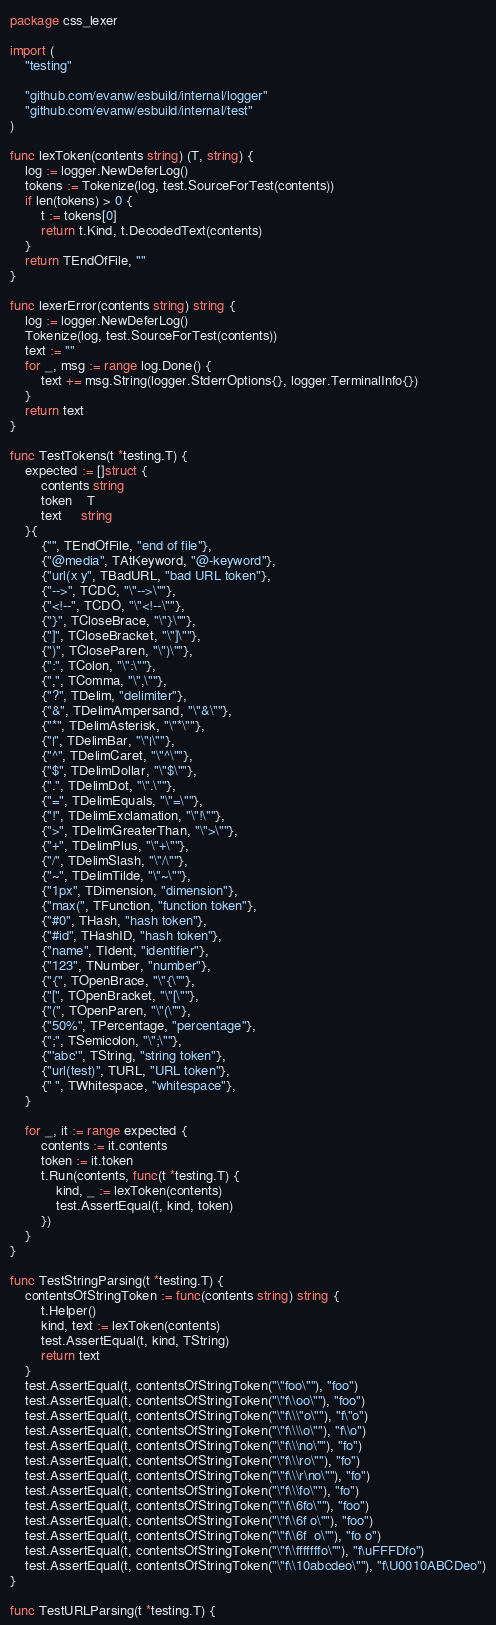Convert code to text. <code><loc_0><loc_0><loc_500><loc_500><_Go_>package css_lexer

import (
	"testing"

	"github.com/evanw/esbuild/internal/logger"
	"github.com/evanw/esbuild/internal/test"
)

func lexToken(contents string) (T, string) {
	log := logger.NewDeferLog()
	tokens := Tokenize(log, test.SourceForTest(contents))
	if len(tokens) > 0 {
		t := tokens[0]
		return t.Kind, t.DecodedText(contents)
	}
	return TEndOfFile, ""
}

func lexerError(contents string) string {
	log := logger.NewDeferLog()
	Tokenize(log, test.SourceForTest(contents))
	text := ""
	for _, msg := range log.Done() {
		text += msg.String(logger.StderrOptions{}, logger.TerminalInfo{})
	}
	return text
}

func TestTokens(t *testing.T) {
	expected := []struct {
		contents string
		token    T
		text     string
	}{
		{"", TEndOfFile, "end of file"},
		{"@media", TAtKeyword, "@-keyword"},
		{"url(x y", TBadURL, "bad URL token"},
		{"-->", TCDC, "\"-->\""},
		{"<!--", TCDO, "\"<!--\""},
		{"}", TCloseBrace, "\"}\""},
		{"]", TCloseBracket, "\"]\""},
		{")", TCloseParen, "\")\""},
		{":", TColon, "\":\""},
		{",", TComma, "\",\""},
		{"?", TDelim, "delimiter"},
		{"&", TDelimAmpersand, "\"&\""},
		{"*", TDelimAsterisk, "\"*\""},
		{"|", TDelimBar, "\"|\""},
		{"^", TDelimCaret, "\"^\""},
		{"$", TDelimDollar, "\"$\""},
		{".", TDelimDot, "\".\""},
		{"=", TDelimEquals, "\"=\""},
		{"!", TDelimExclamation, "\"!\""},
		{">", TDelimGreaterThan, "\">\""},
		{"+", TDelimPlus, "\"+\""},
		{"/", TDelimSlash, "\"/\""},
		{"~", TDelimTilde, "\"~\""},
		{"1px", TDimension, "dimension"},
		{"max(", TFunction, "function token"},
		{"#0", THash, "hash token"},
		{"#id", THashID, "hash token"},
		{"name", TIdent, "identifier"},
		{"123", TNumber, "number"},
		{"{", TOpenBrace, "\"{\""},
		{"[", TOpenBracket, "\"[\""},
		{"(", TOpenParen, "\"(\""},
		{"50%", TPercentage, "percentage"},
		{";", TSemicolon, "\";\""},
		{"'abc'", TString, "string token"},
		{"url(test)", TURL, "URL token"},
		{" ", TWhitespace, "whitespace"},
	}

	for _, it := range expected {
		contents := it.contents
		token := it.token
		t.Run(contents, func(t *testing.T) {
			kind, _ := lexToken(contents)
			test.AssertEqual(t, kind, token)
		})
	}
}

func TestStringParsing(t *testing.T) {
	contentsOfStringToken := func(contents string) string {
		t.Helper()
		kind, text := lexToken(contents)
		test.AssertEqual(t, kind, TString)
		return text
	}
	test.AssertEqual(t, contentsOfStringToken("\"foo\""), "foo")
	test.AssertEqual(t, contentsOfStringToken("\"f\\oo\""), "foo")
	test.AssertEqual(t, contentsOfStringToken("\"f\\\"o\""), "f\"o")
	test.AssertEqual(t, contentsOfStringToken("\"f\\\\o\""), "f\\o")
	test.AssertEqual(t, contentsOfStringToken("\"f\\\no\""), "fo")
	test.AssertEqual(t, contentsOfStringToken("\"f\\\ro\""), "fo")
	test.AssertEqual(t, contentsOfStringToken("\"f\\\r\no\""), "fo")
	test.AssertEqual(t, contentsOfStringToken("\"f\\\fo\""), "fo")
	test.AssertEqual(t, contentsOfStringToken("\"f\\6fo\""), "foo")
	test.AssertEqual(t, contentsOfStringToken("\"f\\6f o\""), "foo")
	test.AssertEqual(t, contentsOfStringToken("\"f\\6f  o\""), "fo o")
	test.AssertEqual(t, contentsOfStringToken("\"f\\fffffffo\""), "f\uFFFDfo")
	test.AssertEqual(t, contentsOfStringToken("\"f\\10abcdeo\""), "f\U0010ABCDeo")
}

func TestURLParsing(t *testing.T) {</code> 